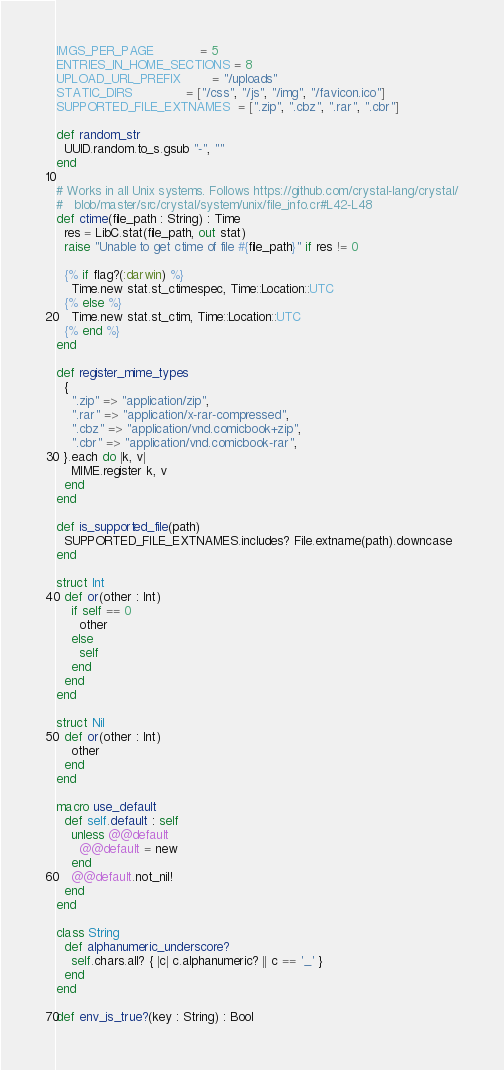<code> <loc_0><loc_0><loc_500><loc_500><_Crystal_>IMGS_PER_PAGE            = 5
ENTRIES_IN_HOME_SECTIONS = 8
UPLOAD_URL_PREFIX        = "/uploads"
STATIC_DIRS              = ["/css", "/js", "/img", "/favicon.ico"]
SUPPORTED_FILE_EXTNAMES  = [".zip", ".cbz", ".rar", ".cbr"]

def random_str
  UUID.random.to_s.gsub "-", ""
end

# Works in all Unix systems. Follows https://github.com/crystal-lang/crystal/
#   blob/master/src/crystal/system/unix/file_info.cr#L42-L48
def ctime(file_path : String) : Time
  res = LibC.stat(file_path, out stat)
  raise "Unable to get ctime of file #{file_path}" if res != 0

  {% if flag?(:darwin) %}
    Time.new stat.st_ctimespec, Time::Location::UTC
  {% else %}
    Time.new stat.st_ctim, Time::Location::UTC
  {% end %}
end

def register_mime_types
  {
    ".zip" => "application/zip",
    ".rar" => "application/x-rar-compressed",
    ".cbz" => "application/vnd.comicbook+zip",
    ".cbr" => "application/vnd.comicbook-rar",
  }.each do |k, v|
    MIME.register k, v
  end
end

def is_supported_file(path)
  SUPPORTED_FILE_EXTNAMES.includes? File.extname(path).downcase
end

struct Int
  def or(other : Int)
    if self == 0
      other
    else
      self
    end
  end
end

struct Nil
  def or(other : Int)
    other
  end
end

macro use_default
  def self.default : self
    unless @@default
      @@default = new
    end
    @@default.not_nil!
  end
end

class String
  def alphanumeric_underscore?
    self.chars.all? { |c| c.alphanumeric? || c == '_' }
  end
end

def env_is_true?(key : String) : Bool</code> 